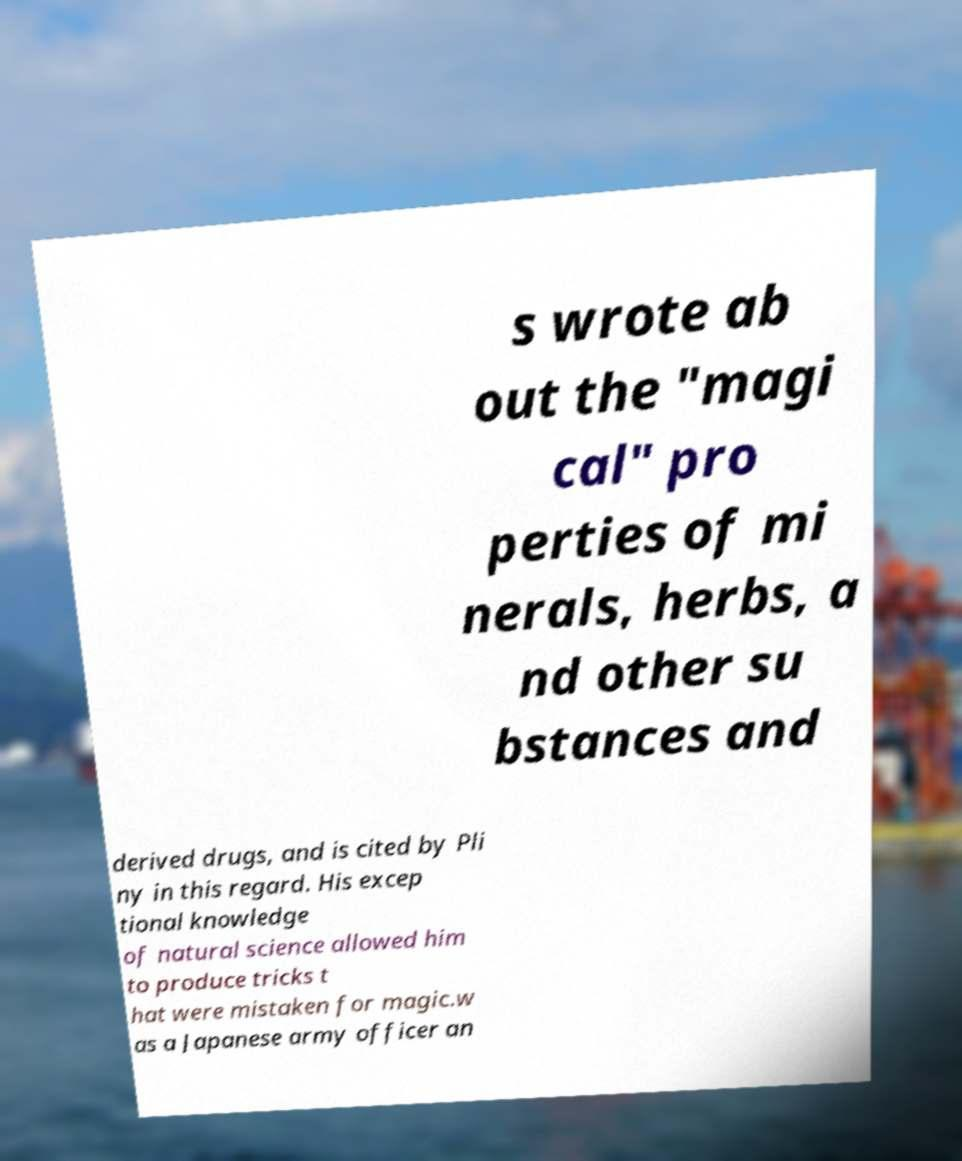What messages or text are displayed in this image? I need them in a readable, typed format. s wrote ab out the "magi cal" pro perties of mi nerals, herbs, a nd other su bstances and derived drugs, and is cited by Pli ny in this regard. His excep tional knowledge of natural science allowed him to produce tricks t hat were mistaken for magic.w as a Japanese army officer an 